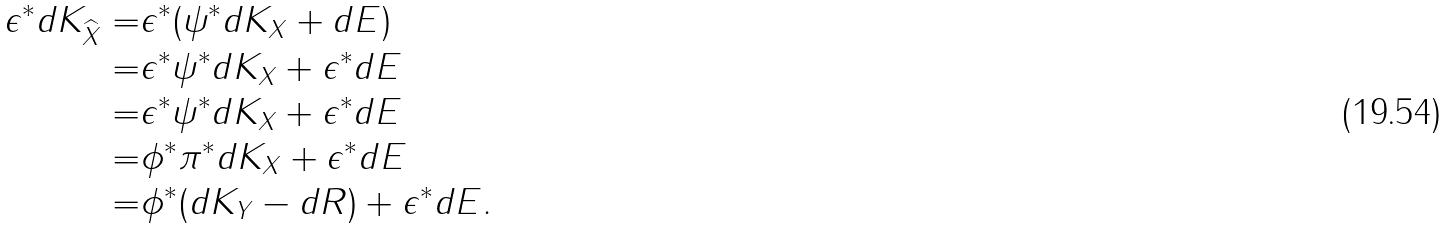<formula> <loc_0><loc_0><loc_500><loc_500>\epsilon ^ { \ast } d K _ { \widehat { X } } = & \epsilon ^ { \ast } ( \psi ^ { \ast } d K _ { X } + d E ) \\ = & \epsilon ^ { \ast } \psi ^ { \ast } d K _ { X } + \epsilon ^ { \ast } d E \\ = & \epsilon ^ { \ast } \psi ^ { \ast } d K _ { X } + \epsilon ^ { \ast } d E \\ = & \phi ^ { \ast } \pi ^ { \ast } d K _ { X } + \epsilon ^ { \ast } d E \\ = & \phi ^ { \ast } ( d K _ { Y } - d R ) + \epsilon ^ { \ast } d E .</formula> 